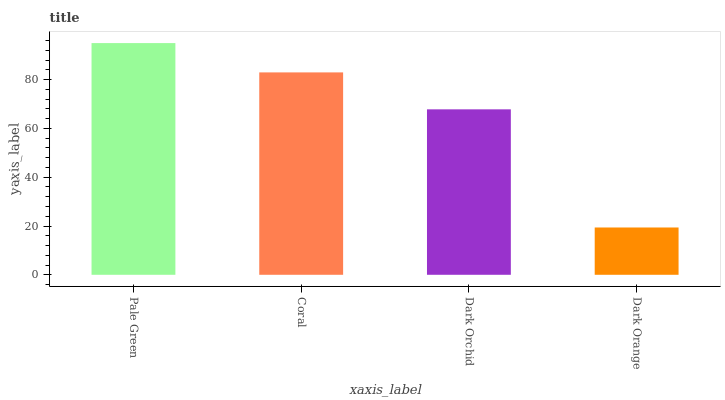Is Dark Orange the minimum?
Answer yes or no. Yes. Is Pale Green the maximum?
Answer yes or no. Yes. Is Coral the minimum?
Answer yes or no. No. Is Coral the maximum?
Answer yes or no. No. Is Pale Green greater than Coral?
Answer yes or no. Yes. Is Coral less than Pale Green?
Answer yes or no. Yes. Is Coral greater than Pale Green?
Answer yes or no. No. Is Pale Green less than Coral?
Answer yes or no. No. Is Coral the high median?
Answer yes or no. Yes. Is Dark Orchid the low median?
Answer yes or no. Yes. Is Dark Orchid the high median?
Answer yes or no. No. Is Pale Green the low median?
Answer yes or no. No. 